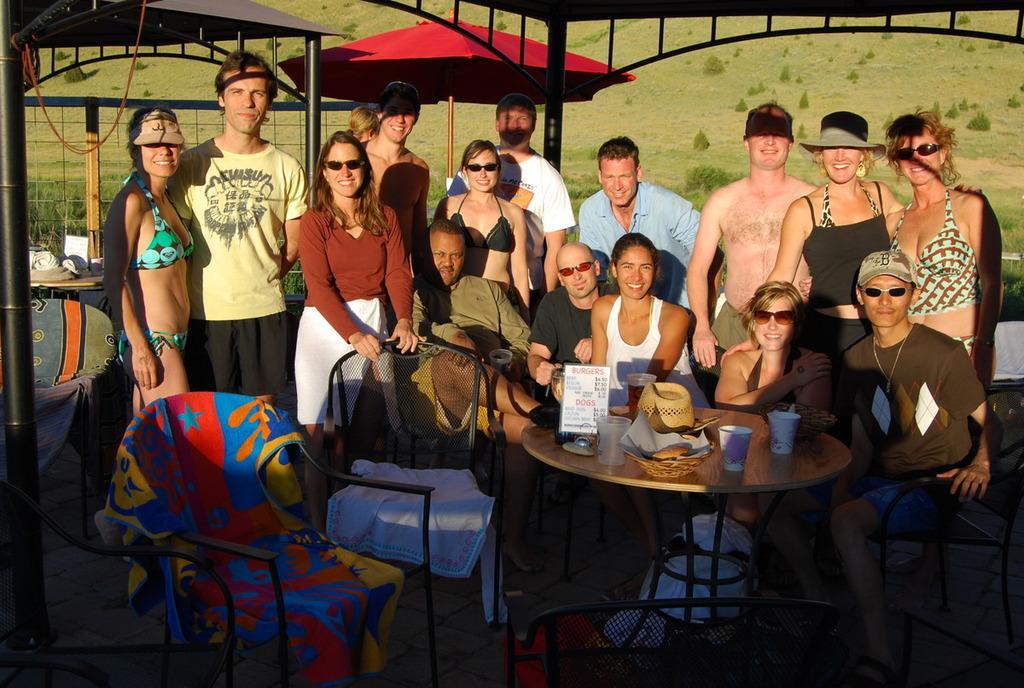How would you summarize this image in a sentence or two? In this image i can see a group of people sitting on chairs and few of them are standing. In the background i can see few tents, few trees and the ground. 